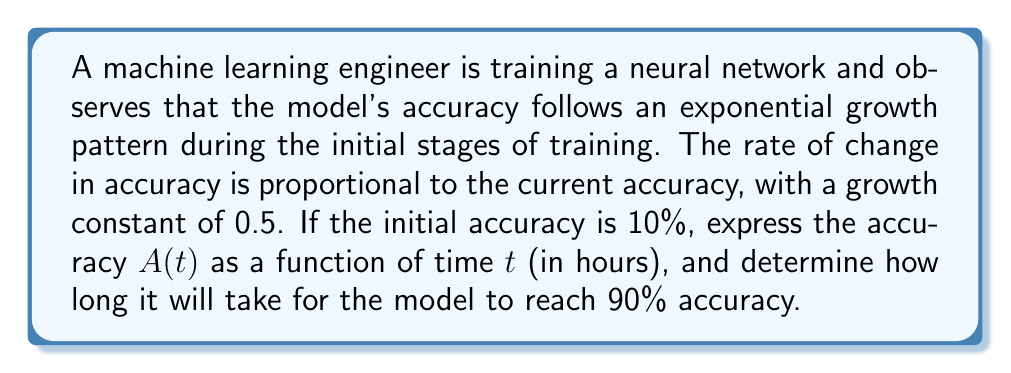Teach me how to tackle this problem. To solve this problem, we need to use a first-order differential equation that models exponential growth. Let's approach this step-by-step:

1) The rate of change in accuracy is proportional to the current accuracy. This can be expressed as:

   $$\frac{dA}{dt} = kA$$

   where $k$ is the growth constant, which is given as 0.5.

2) We're given that the initial accuracy is 10% or 0.1. This is our initial condition:

   $A(0) = 0.1$

3) The general solution to this differential equation is:

   $$A(t) = Ce^{kt}$$

   where $C$ is a constant we need to determine using the initial condition.

4) Using the initial condition:

   $0.1 = Ce^{k(0)}$
   $0.1 = C$

5) Therefore, our specific solution is:

   $$A(t) = 0.1e^{0.5t}$$

6) To find when the accuracy reaches 90% (0.9), we solve:

   $0.9 = 0.1e^{0.5t}$

7) Taking the natural log of both sides:

   $\ln(9) = 0.5t$

8) Solving for $t$:

   $$t = \frac{\ln(9)}{0.5} \approx 4.39$$

Therefore, it will take approximately 4.39 hours for the model to reach 90% accuracy.
Answer: The accuracy as a function of time is $A(t) = 0.1e^{0.5t}$, and it will take approximately 4.39 hours for the model to reach 90% accuracy. 